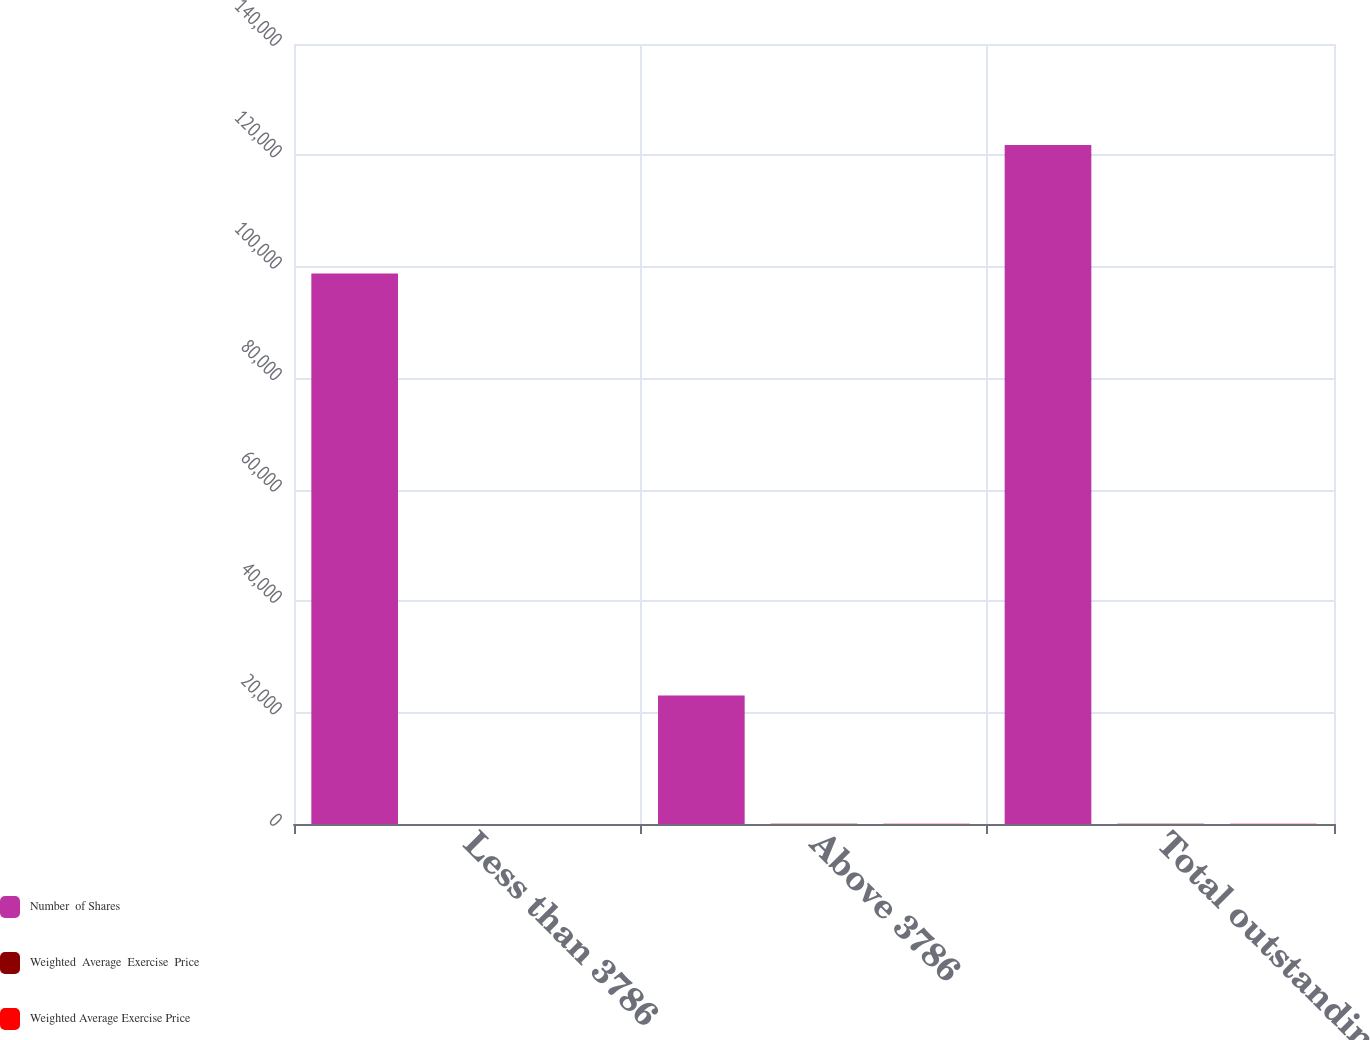<chart> <loc_0><loc_0><loc_500><loc_500><stacked_bar_chart><ecel><fcel>Less than 3786<fcel>Above 3786<fcel>Total outstanding<nl><fcel>Number  of Shares<fcel>98804<fcel>23068<fcel>121872<nl><fcel>Weighted  Average  Exercise  Price<fcel>19.59<fcel>45.1<fcel>24.42<nl><fcel>Weighted Average Exercise Price<fcel>21.52<fcel>45.27<fcel>29.2<nl></chart> 